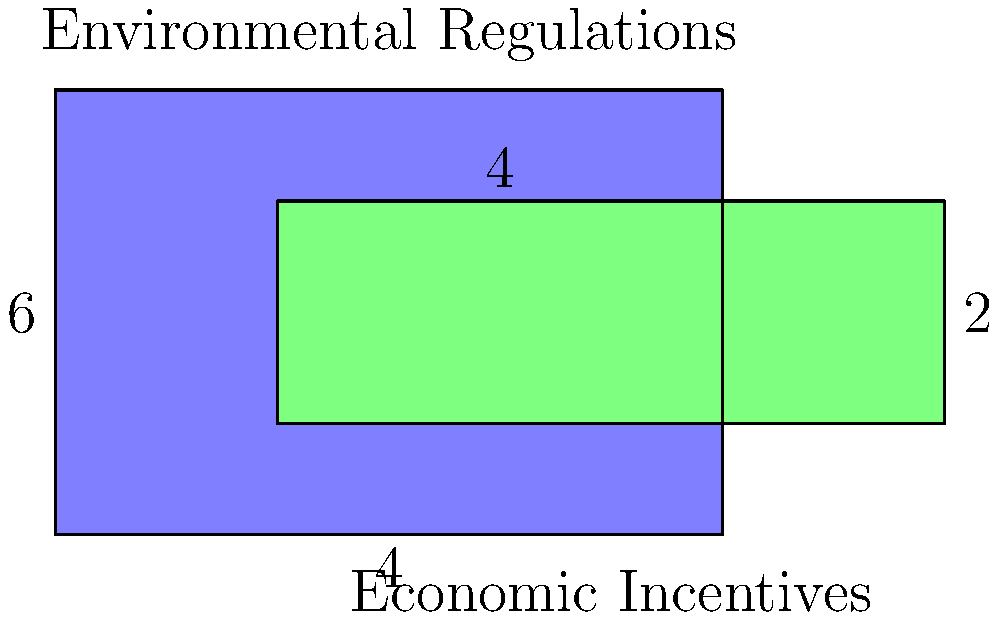In the diagram, two rectangles represent the areas of influence for environmental regulations (blue) and economic incentives (green) in climate policy. The blue rectangle measures 6 units by 4 units, while the green rectangle measures 6 units by 2 units. If the overlapping region represents the intersection of these two approaches, what percentage of the total area covered by both approaches does this intersection represent? To solve this problem, let's follow these steps:

1) Calculate the area of the blue rectangle (environmental regulations):
   $A_{blue} = 6 \times 4 = 24$ square units

2) Calculate the area of the green rectangle (economic incentives):
   $A_{green} = 6 \times 2 = 12$ square units

3) Calculate the area of the overlapping region:
   Width of overlap = 4 units
   Height of overlap = 2 units
   $A_{overlap} = 4 \times 2 = 8$ square units

4) Calculate the total area covered by both approaches:
   $A_{total} = A_{blue} + A_{green} - A_{overlap}$
   $A_{total} = 24 + 12 - 8 = 28$ square units

5) Calculate the percentage of the overlapping area:
   Percentage = $(A_{overlap} \div A_{total}) \times 100\%$
   $= (8 \div 28) \times 100\% = 0.2857 \times 100\% \approx 28.57\%$

Therefore, the overlapping region represents approximately 28.57% of the total area covered by both approaches.
Answer: 28.57% 